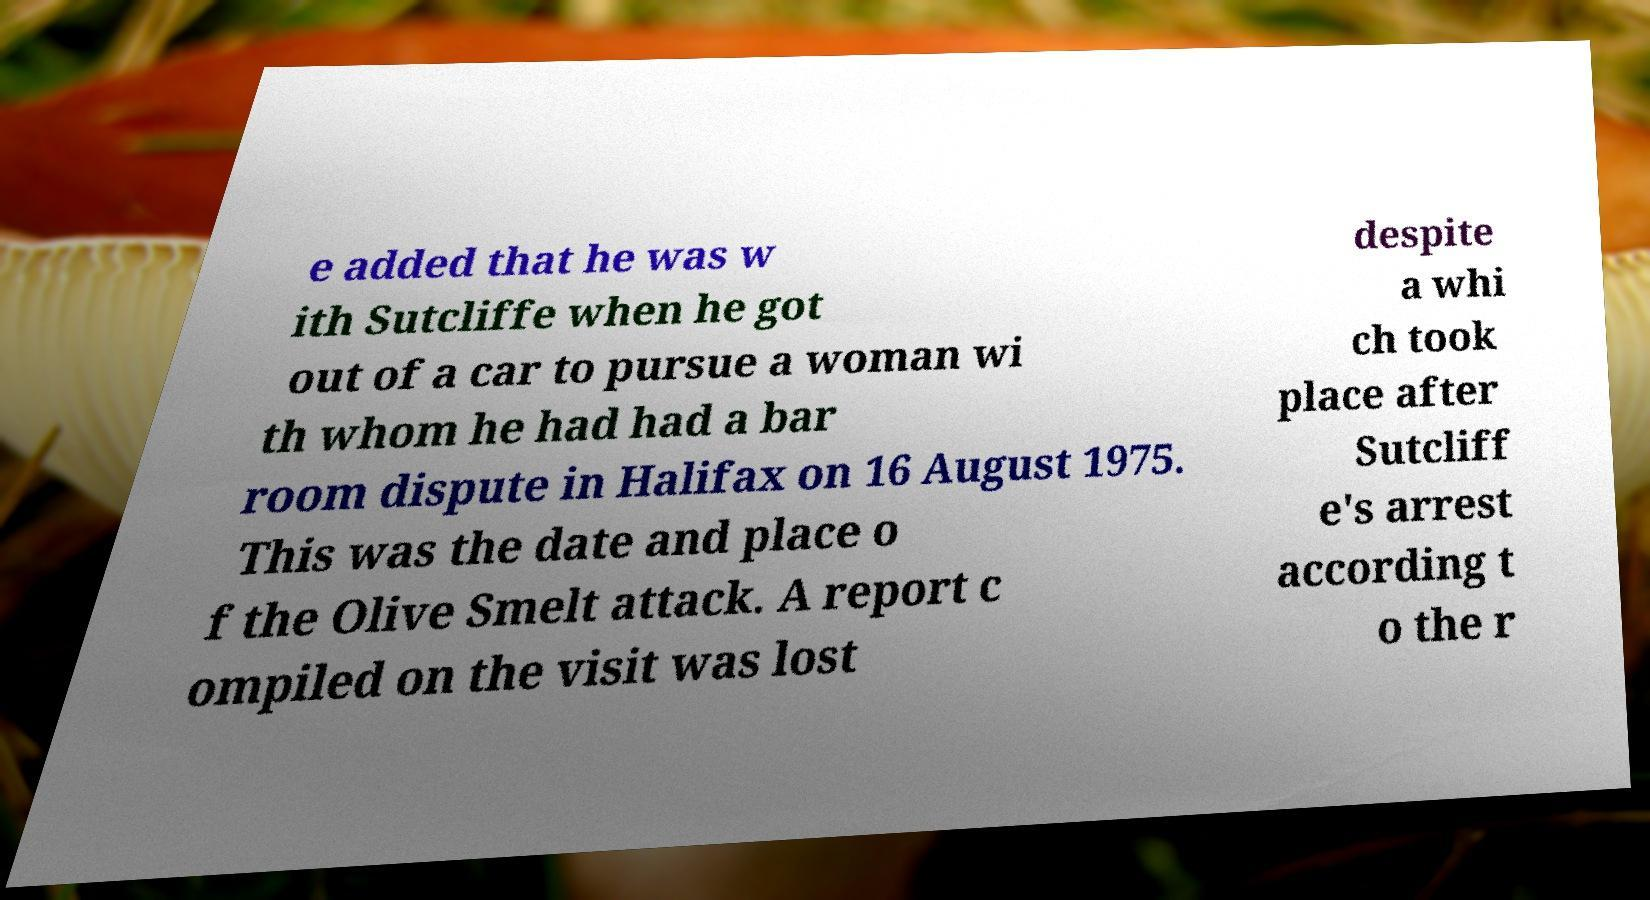I need the written content from this picture converted into text. Can you do that? e added that he was w ith Sutcliffe when he got out of a car to pursue a woman wi th whom he had had a bar room dispute in Halifax on 16 August 1975. This was the date and place o f the Olive Smelt attack. A report c ompiled on the visit was lost despite a whi ch took place after Sutcliff e's arrest according t o the r 